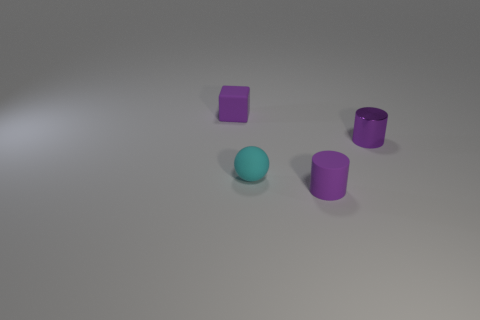Add 4 small matte balls. How many objects exist? 8 Subtract 0 cyan cylinders. How many objects are left? 4 Subtract all balls. How many objects are left? 3 Subtract all tiny green metal balls. Subtract all tiny rubber objects. How many objects are left? 1 Add 1 purple matte blocks. How many purple matte blocks are left? 2 Add 2 purple spheres. How many purple spheres exist? 2 